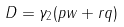<formula> <loc_0><loc_0><loc_500><loc_500>D = \gamma _ { 2 } ( p w + r q )</formula> 